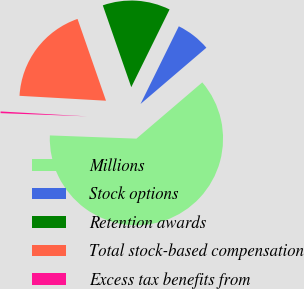Convert chart. <chart><loc_0><loc_0><loc_500><loc_500><pie_chart><fcel>Millions<fcel>Stock options<fcel>Retention awards<fcel>Total stock-based compensation<fcel>Excess tax benefits from<nl><fcel>61.85%<fcel>6.46%<fcel>12.62%<fcel>18.77%<fcel>0.31%<nl></chart> 